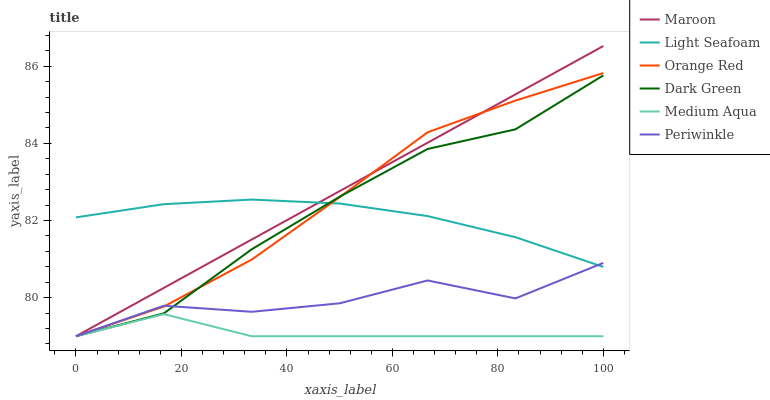Does Medium Aqua have the minimum area under the curve?
Answer yes or no. Yes. Does Maroon have the maximum area under the curve?
Answer yes or no. Yes. Does Periwinkle have the minimum area under the curve?
Answer yes or no. No. Does Periwinkle have the maximum area under the curve?
Answer yes or no. No. Is Maroon the smoothest?
Answer yes or no. Yes. Is Periwinkle the roughest?
Answer yes or no. Yes. Is Medium Aqua the smoothest?
Answer yes or no. No. Is Medium Aqua the roughest?
Answer yes or no. No. Does Maroon have the lowest value?
Answer yes or no. Yes. Does Light Seafoam have the lowest value?
Answer yes or no. No. Does Maroon have the highest value?
Answer yes or no. Yes. Does Periwinkle have the highest value?
Answer yes or no. No. Is Medium Aqua less than Light Seafoam?
Answer yes or no. Yes. Is Light Seafoam greater than Medium Aqua?
Answer yes or no. Yes. Does Dark Green intersect Periwinkle?
Answer yes or no. Yes. Is Dark Green less than Periwinkle?
Answer yes or no. No. Is Dark Green greater than Periwinkle?
Answer yes or no. No. Does Medium Aqua intersect Light Seafoam?
Answer yes or no. No. 